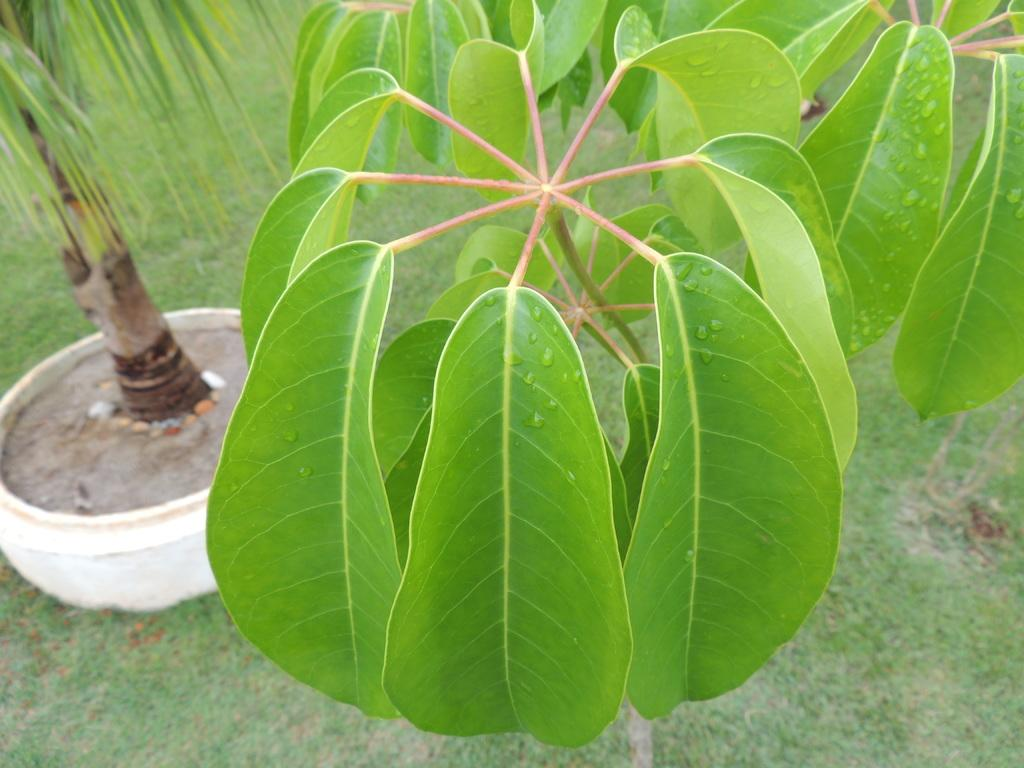What type of vegetation can be seen in the image? There are multiple plants and grass visible in the image. Can you describe the surface on which one of the plants is placed? There is a white object in the image, on which a plant is placed. What type of apparel is the plant wearing in the image? Plants do not wear apparel, so this question cannot be answered. 